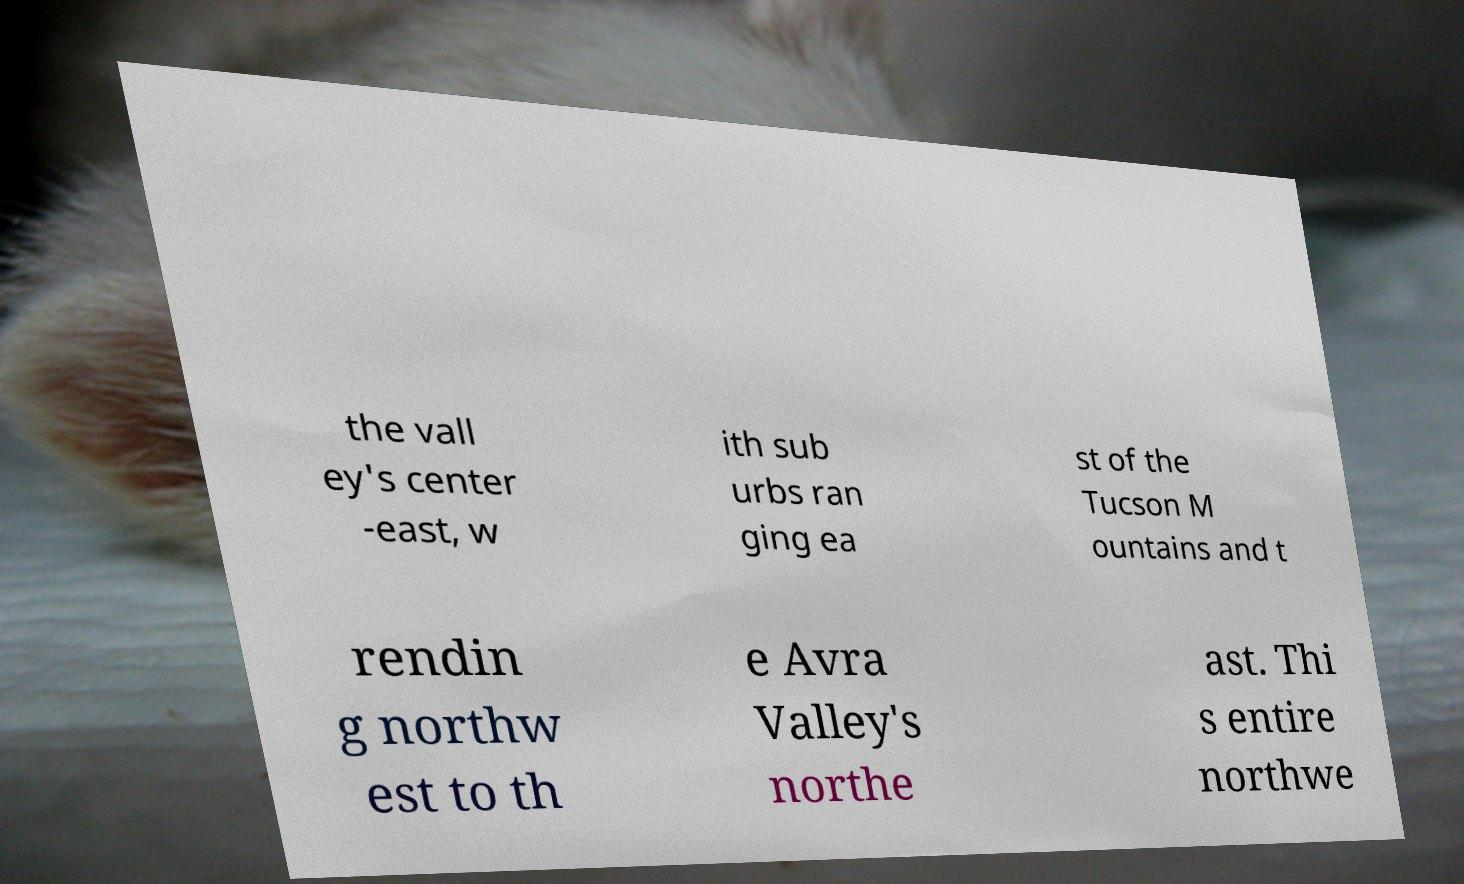Please read and relay the text visible in this image. What does it say? the vall ey's center -east, w ith sub urbs ran ging ea st of the Tucson M ountains and t rendin g northw est to th e Avra Valley's northe ast. Thi s entire northwe 